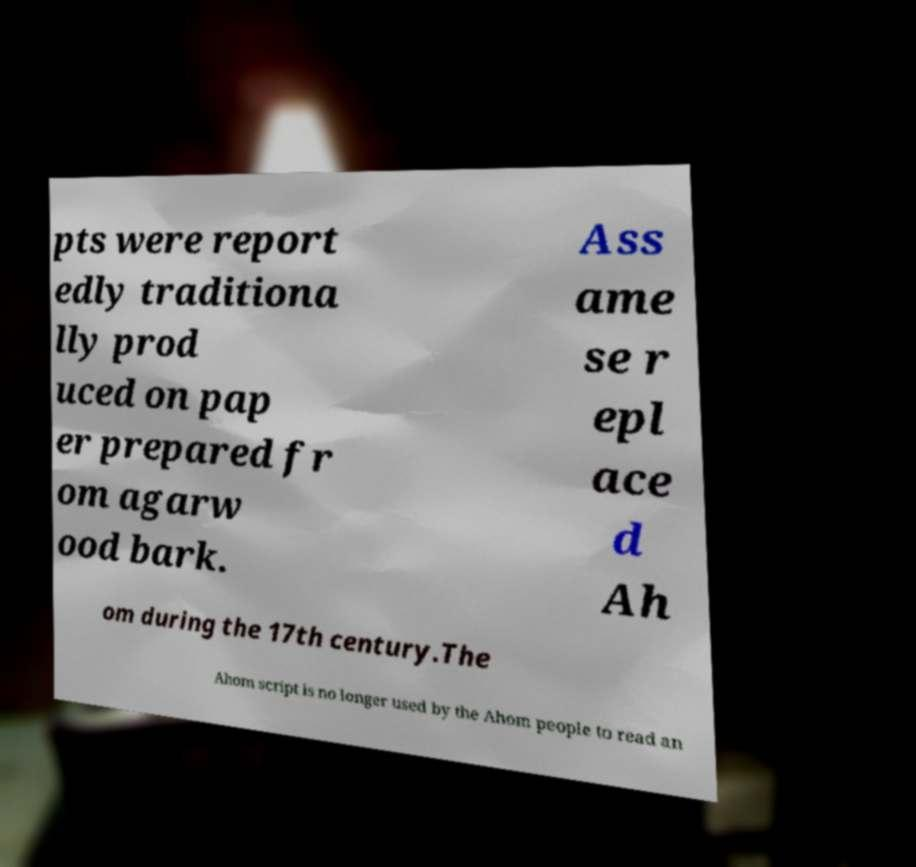Can you read and provide the text displayed in the image?This photo seems to have some interesting text. Can you extract and type it out for me? pts were report edly traditiona lly prod uced on pap er prepared fr om agarw ood bark. Ass ame se r epl ace d Ah om during the 17th century.The Ahom script is no longer used by the Ahom people to read an 